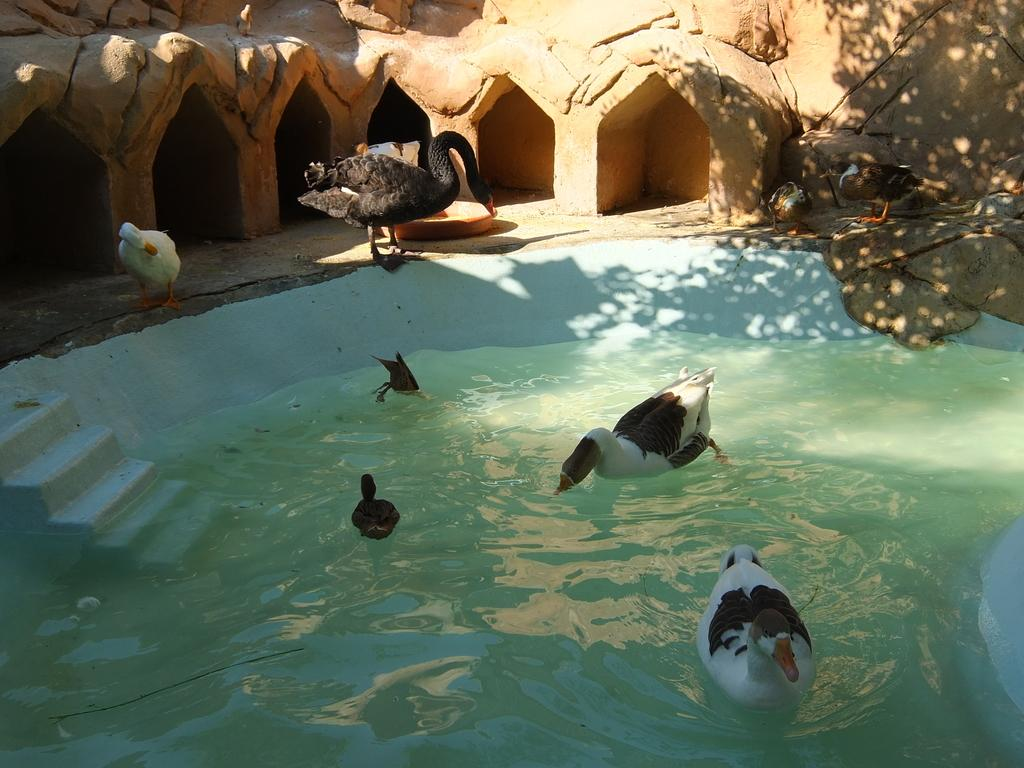What is the main feature in the image? There is a pool in the image. What animals can be seen in the pool? There are ducks in the pool. What can be seen in the background of the image? There is a wall in the background of the image. What architectural feature is on the left side of the image? There are stairs on the left side of the image. What other living creatures are visible in the image? Birds are visible in the image. What type of rings can be seen hanging from the canvas in the middle of the image? There is no canvas or rings present in the image. 